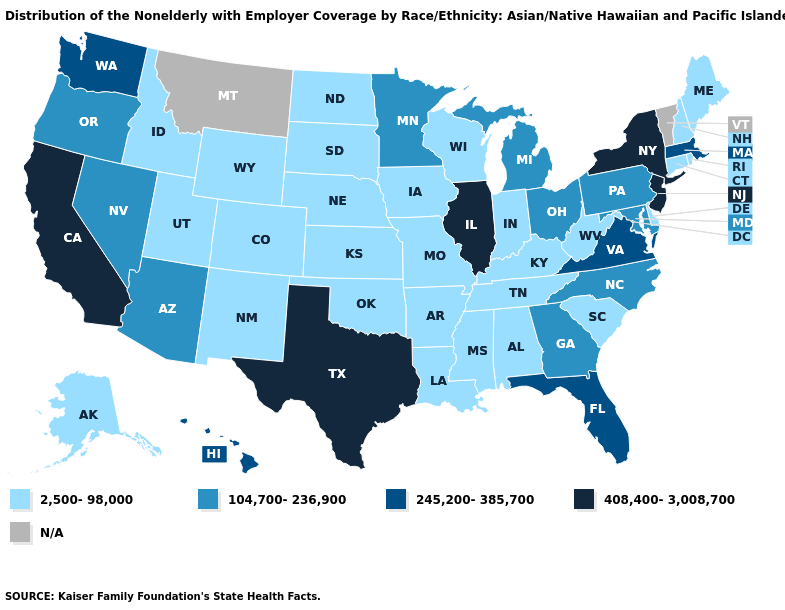Among the states that border Utah , which have the highest value?
Quick response, please. Arizona, Nevada. Does the map have missing data?
Write a very short answer. Yes. Among the states that border Maryland , which have the lowest value?
Be succinct. Delaware, West Virginia. Among the states that border New Mexico , does Texas have the highest value?
Give a very brief answer. Yes. Name the states that have a value in the range 408,400-3,008,700?
Quick response, please. California, Illinois, New Jersey, New York, Texas. What is the lowest value in the South?
Answer briefly. 2,500-98,000. Name the states that have a value in the range 245,200-385,700?
Quick response, please. Florida, Hawaii, Massachusetts, Virginia, Washington. Name the states that have a value in the range N/A?
Quick response, please. Montana, Vermont. Does Illinois have the highest value in the USA?
Quick response, please. Yes. What is the highest value in the Northeast ?
Short answer required. 408,400-3,008,700. Name the states that have a value in the range 104,700-236,900?
Be succinct. Arizona, Georgia, Maryland, Michigan, Minnesota, Nevada, North Carolina, Ohio, Oregon, Pennsylvania. Does Nebraska have the lowest value in the MidWest?
Quick response, please. Yes. 